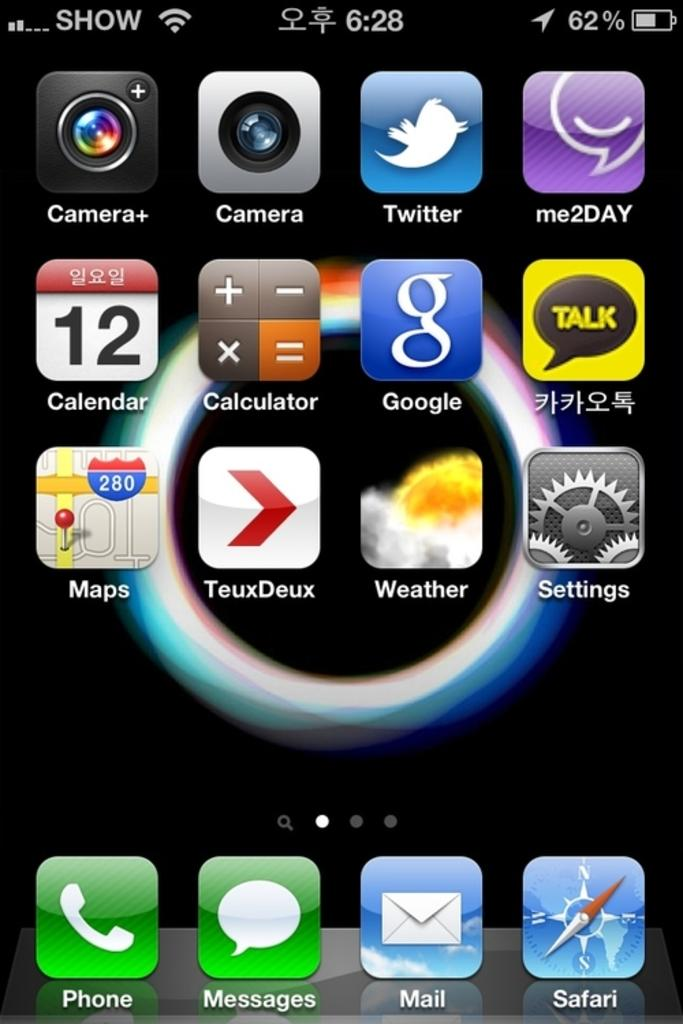<image>
Present a compact description of the photo's key features. A screenshot of a page of apps including Twitter. 